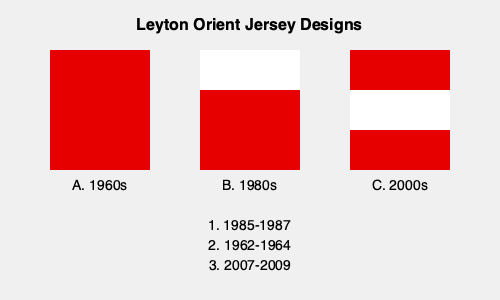Match the Leyton Orient jersey designs (A, B, C) to their corresponding years (1, 2, 3). Which combination is correct? To match the Leyton Orient jersey designs to their corresponding years, we need to consider the evolution of the club's iconic red jerseys:

1. Design A shows a solid red jersey, which is typical of the 1960s era. This matches with option 2 (1962-1964).

2. Design B features a white upper third of the jersey with the rest in red. This design was popular in the 1980s, corresponding to option 1 (1985-1987).

3. Design C shows a red jersey with a white horizontal stripe in the middle. This more modern design aligns with the 2000s, matching option 3 (2007-2009).

Therefore, the correct combination is:
A - 2 (1962-1964)
B - 1 (1985-1987)
C - 3 (2007-2009)
Answer: A2, B1, C3 